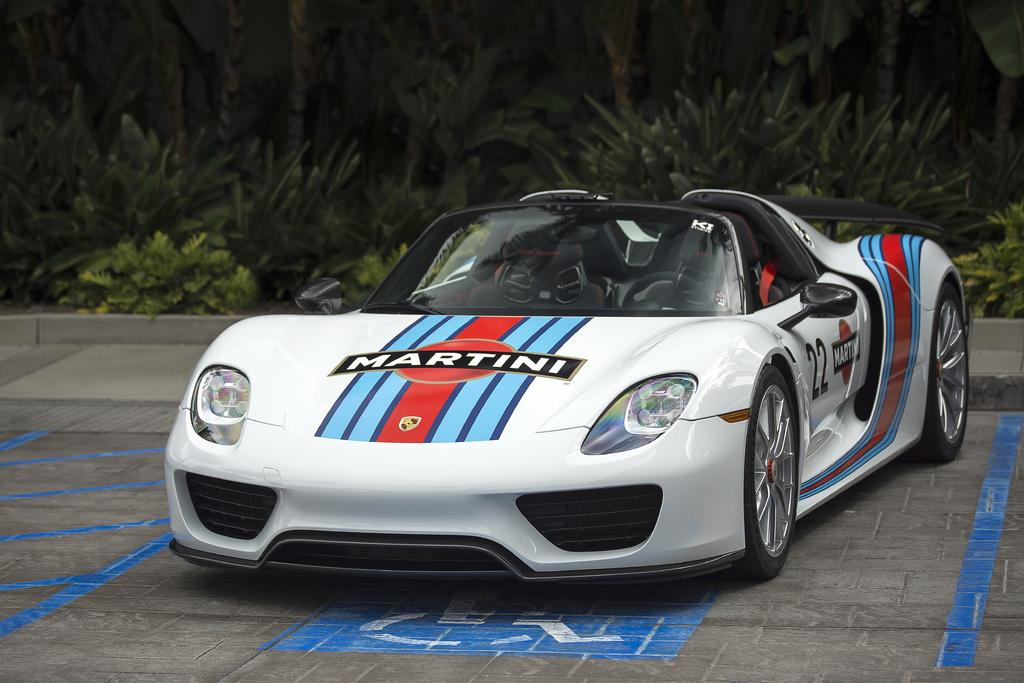What is the main subject of the image? There is a car in the image. Where is the car located? The car is on the road. What can be seen in the background of the image? There are plants in the background of the image. How many babies are sitting on the blade in the image? There are no babies or blades present in the image. 